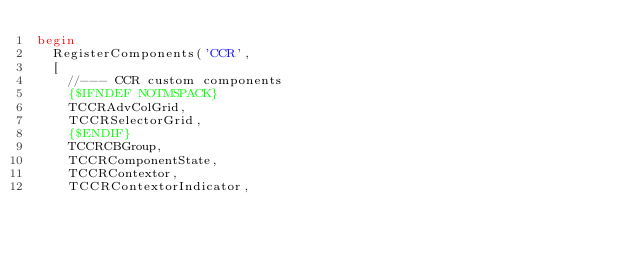<code> <loc_0><loc_0><loc_500><loc_500><_Pascal_>begin
  RegisterComponents('CCR',
  [
    //--- CCR custom components
    {$IFNDEF NOTMSPACK}
    TCCRAdvColGrid,
    TCCRSelectorGrid,
    {$ENDIF}
    TCCRCBGroup,
    TCCRComponentState,
    TCCRContextor,
    TCCRContextorIndicator,</code> 